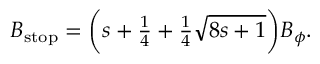<formula> <loc_0><loc_0><loc_500><loc_500>\begin{array} { r } { B _ { s t o p } = \left ( s + \frac { 1 } { 4 } + \frac { 1 } { 4 } \sqrt { 8 s + 1 } \right ) B _ { \phi } . } \end{array}</formula> 